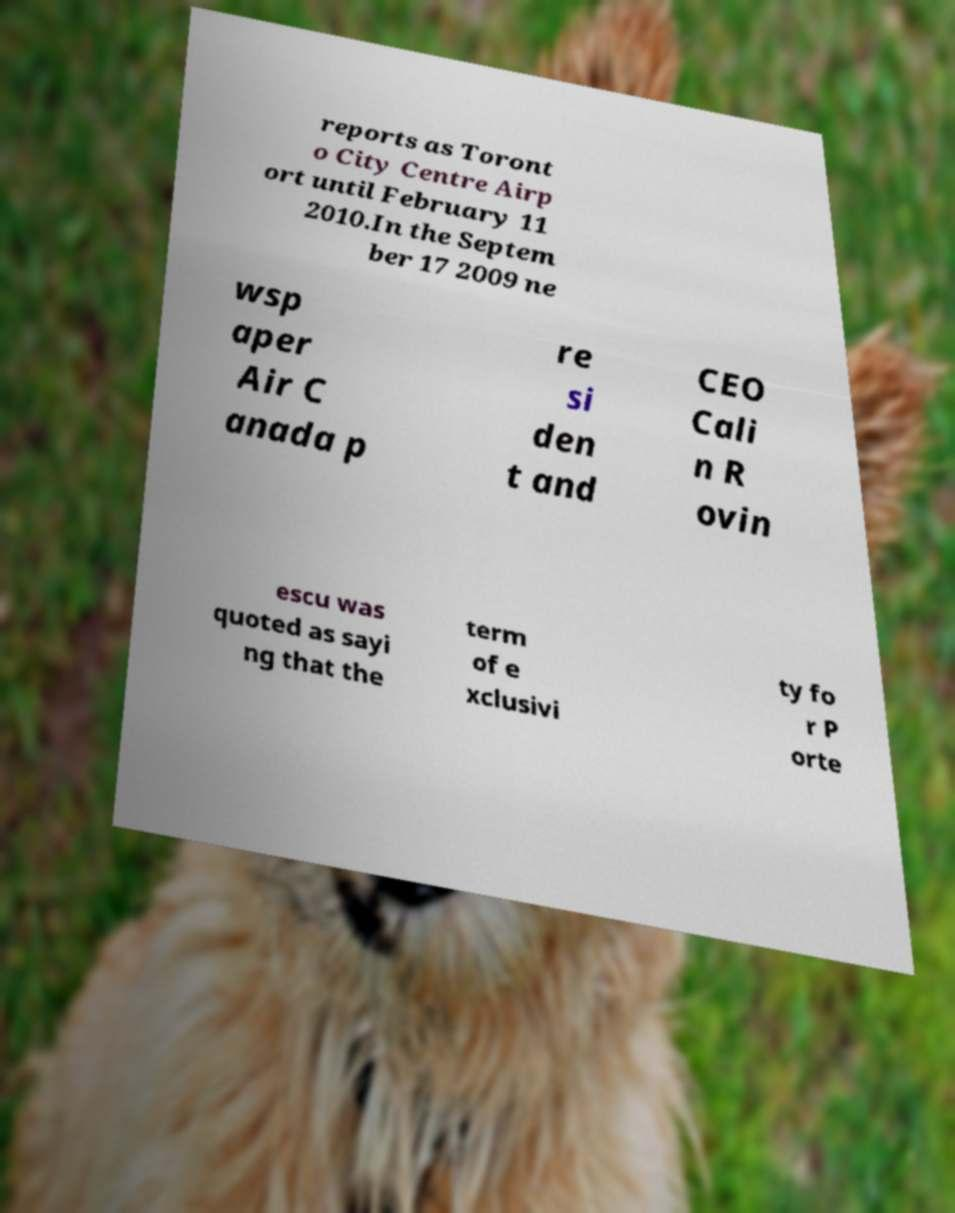Please read and relay the text visible in this image. What does it say? reports as Toront o City Centre Airp ort until February 11 2010.In the Septem ber 17 2009 ne wsp aper Air C anada p re si den t and CEO Cali n R ovin escu was quoted as sayi ng that the term of e xclusivi ty fo r P orte 